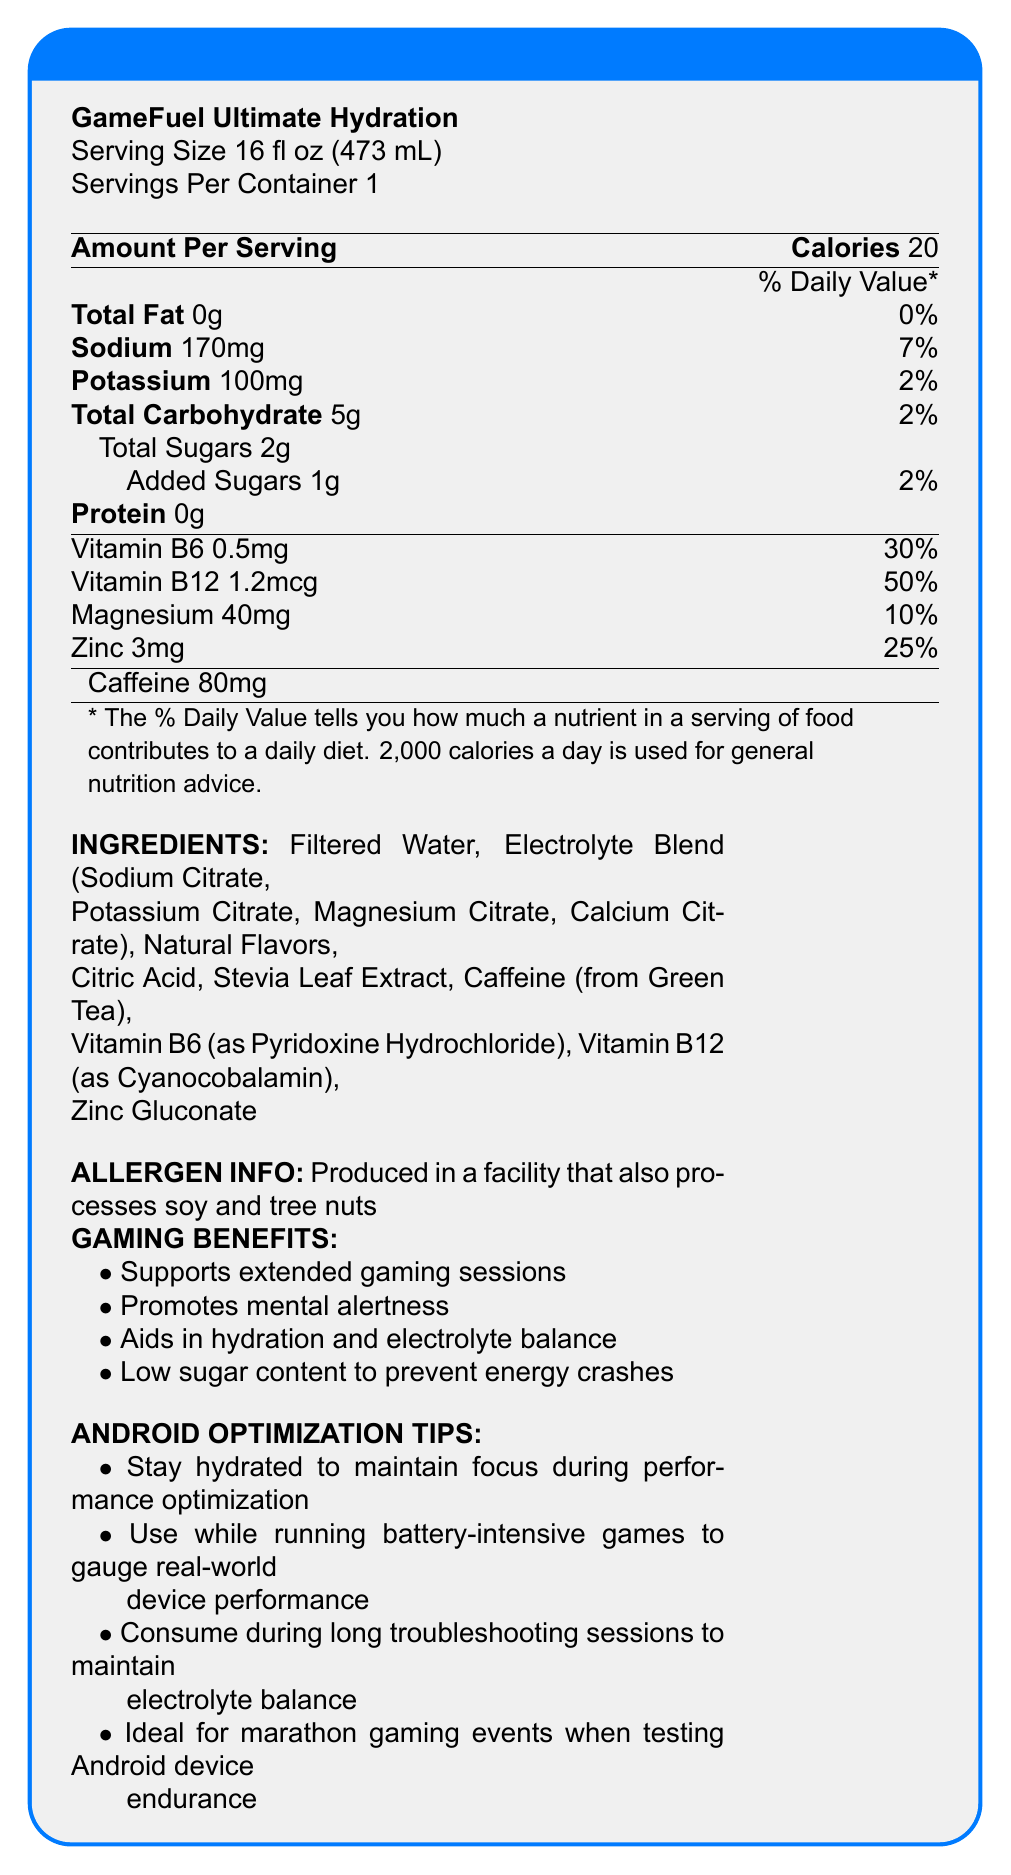what is the serving size for GameFuel Ultimate Hydration? The serving size is explicitly listed at the top of the Nutrition Facts label.
Answer: 16 fl oz (473 mL) how much sodium is in one serving of GameFuel Ultimate Hydration? The amount of sodium is listed under the Sodium section as 170mg.
Answer: 170mg what is the percentage of daily value for potassium in this sports drink? Under the Potassium section, it states that the potassium contributes 2% to the daily value.
Answer: 2% how much caffeine does GameFuel Ultimate Hydration contain? The amount of caffeine is listed separately toward the bottom of the Nutrition Facts section as 80mg.
Answer: 80mg how much total carbohydrate is in one serving? The total carbohydrate content is explicitly stated under the Total Carbohydrate section as 5g.
Answer: 5g which of the following is an ingredient in the electrolyte blend of GameFuel Ultimate Hydration? A. Sodium Chloride B. Magnesium Citrate C. Vitamin C D. Aspartame The document lists Magnesium Citrate as one of the ingredients in the electrolyte blend.
Answer: B how many milligrams of magnesium are in one serving? The magnesium content is shown under the vitamins and minerals section as 40mg.
Answer: 40mg which vitamin has the highest percentage of daily value in this drink? A. Vitamin B6 B. Vitamin B12 C. Magnesium D. Zinc Vitamin B12 has the highest daily value percentage at 50%, compared to Vitamin B6 at 30%, Magnesium at 10%, and Zinc at 25%.
Answer: B is GameFuel Ultimate Hydration suitable for individuals with soy allergies? The allergen information states that the product is produced in a facility that processes soy, which may not be suitable for individuals with soy allergies.
Answer: No summarize the main benefits of GameFuel Ultimate Hydration specific to extended gaming and Android device use. The document outlines the various gaming benefits and Android optimization tips provided by GameFuel Ultimate Hydration to enhance extended gaming sessions and device performance.
Answer: GameFuel Ultimate Hydration is designed to support extended gaming sessions by promoting mental alertness, aiding hydration and electrolyte balance, and preventing energy crashes with low sugar content. It's also recommended for Android users to stay hydrated during performance optimization, battery-intensive gaming, troubleshooting, and marathon gaming events. how much protein is in each serving of GameFuel Ultimate Hydration? The protein content is listed as 0g under the Protein section.
Answer: 0g what is the daily value percentage for zinc in one serving? The zinc content and daily value percentage are provided under the vitamins and minerals section, indicating it contributes 25% to the daily value.
Answer: 25% does the product contain any added sugars? The label indicates that the product contains 1g of added sugars, which is 2% of the daily value.
Answer: Yes what specific benefits might this drink offer during long troubleshooting sessions on Android devices? The tech support notes mention these specific benefits for prolonged use during troubleshooting on Android devices.
Answer: Reduced eye strain and fatigue, maintained electrolyte balance, and supported cognitive function are there any details on how much vitamin C is in GameFuel Ultimate Hydration? The document does not list any information regarding vitamin C content.
Answer: Not enough information 